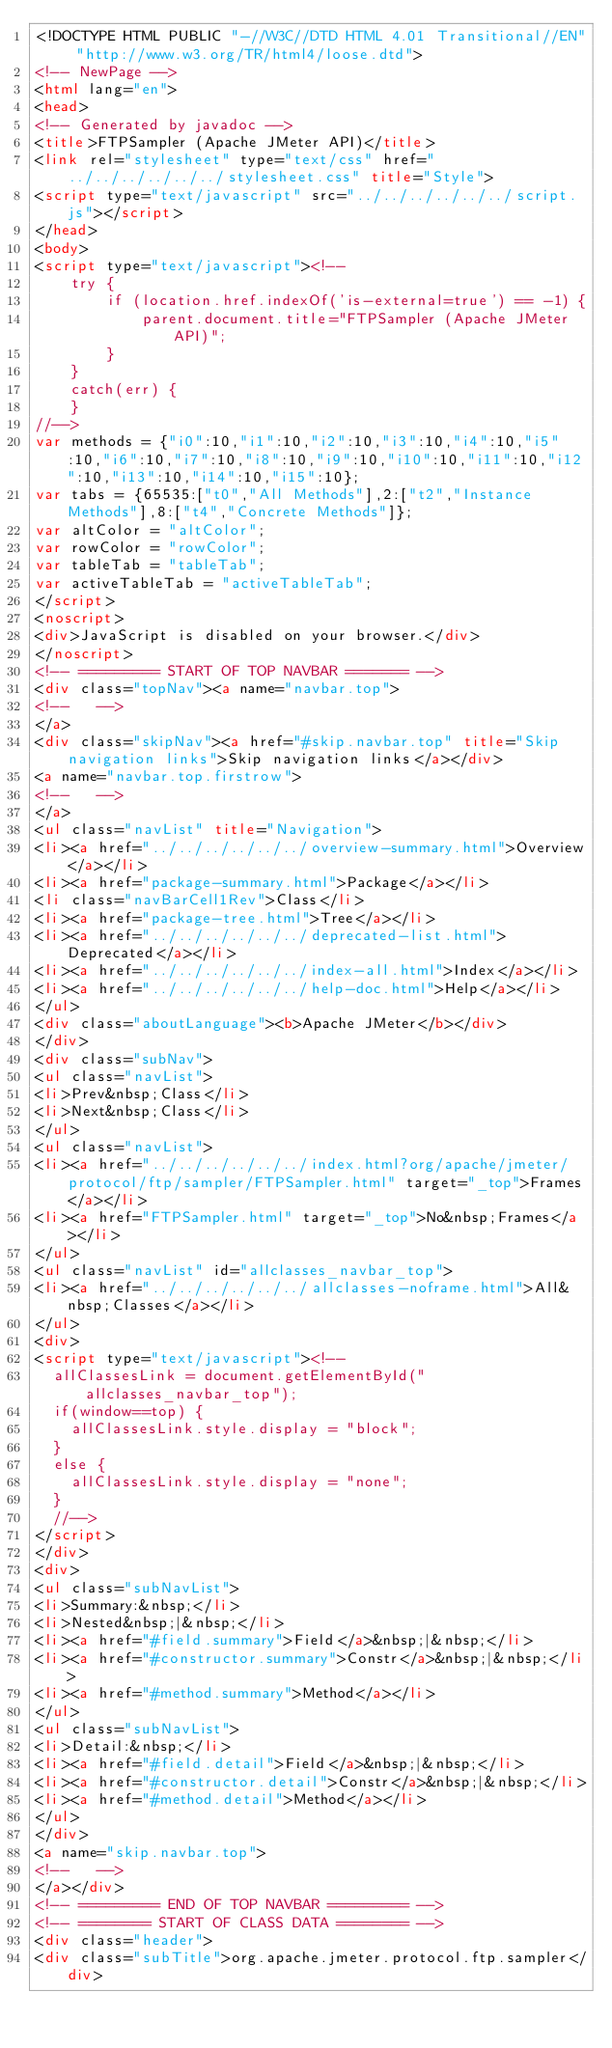Convert code to text. <code><loc_0><loc_0><loc_500><loc_500><_HTML_><!DOCTYPE HTML PUBLIC "-//W3C//DTD HTML 4.01 Transitional//EN" "http://www.w3.org/TR/html4/loose.dtd">
<!-- NewPage -->
<html lang="en">
<head>
<!-- Generated by javadoc -->
<title>FTPSampler (Apache JMeter API)</title>
<link rel="stylesheet" type="text/css" href="../../../../../../stylesheet.css" title="Style">
<script type="text/javascript" src="../../../../../../script.js"></script>
</head>
<body>
<script type="text/javascript"><!--
    try {
        if (location.href.indexOf('is-external=true') == -1) {
            parent.document.title="FTPSampler (Apache JMeter API)";
        }
    }
    catch(err) {
    }
//-->
var methods = {"i0":10,"i1":10,"i2":10,"i3":10,"i4":10,"i5":10,"i6":10,"i7":10,"i8":10,"i9":10,"i10":10,"i11":10,"i12":10,"i13":10,"i14":10,"i15":10};
var tabs = {65535:["t0","All Methods"],2:["t2","Instance Methods"],8:["t4","Concrete Methods"]};
var altColor = "altColor";
var rowColor = "rowColor";
var tableTab = "tableTab";
var activeTableTab = "activeTableTab";
</script>
<noscript>
<div>JavaScript is disabled on your browser.</div>
</noscript>
<!-- ========= START OF TOP NAVBAR ======= -->
<div class="topNav"><a name="navbar.top">
<!--   -->
</a>
<div class="skipNav"><a href="#skip.navbar.top" title="Skip navigation links">Skip navigation links</a></div>
<a name="navbar.top.firstrow">
<!--   -->
</a>
<ul class="navList" title="Navigation">
<li><a href="../../../../../../overview-summary.html">Overview</a></li>
<li><a href="package-summary.html">Package</a></li>
<li class="navBarCell1Rev">Class</li>
<li><a href="package-tree.html">Tree</a></li>
<li><a href="../../../../../../deprecated-list.html">Deprecated</a></li>
<li><a href="../../../../../../index-all.html">Index</a></li>
<li><a href="../../../../../../help-doc.html">Help</a></li>
</ul>
<div class="aboutLanguage"><b>Apache JMeter</b></div>
</div>
<div class="subNav">
<ul class="navList">
<li>Prev&nbsp;Class</li>
<li>Next&nbsp;Class</li>
</ul>
<ul class="navList">
<li><a href="../../../../../../index.html?org/apache/jmeter/protocol/ftp/sampler/FTPSampler.html" target="_top">Frames</a></li>
<li><a href="FTPSampler.html" target="_top">No&nbsp;Frames</a></li>
</ul>
<ul class="navList" id="allclasses_navbar_top">
<li><a href="../../../../../../allclasses-noframe.html">All&nbsp;Classes</a></li>
</ul>
<div>
<script type="text/javascript"><!--
  allClassesLink = document.getElementById("allclasses_navbar_top");
  if(window==top) {
    allClassesLink.style.display = "block";
  }
  else {
    allClassesLink.style.display = "none";
  }
  //-->
</script>
</div>
<div>
<ul class="subNavList">
<li>Summary:&nbsp;</li>
<li>Nested&nbsp;|&nbsp;</li>
<li><a href="#field.summary">Field</a>&nbsp;|&nbsp;</li>
<li><a href="#constructor.summary">Constr</a>&nbsp;|&nbsp;</li>
<li><a href="#method.summary">Method</a></li>
</ul>
<ul class="subNavList">
<li>Detail:&nbsp;</li>
<li><a href="#field.detail">Field</a>&nbsp;|&nbsp;</li>
<li><a href="#constructor.detail">Constr</a>&nbsp;|&nbsp;</li>
<li><a href="#method.detail">Method</a></li>
</ul>
</div>
<a name="skip.navbar.top">
<!--   -->
</a></div>
<!-- ========= END OF TOP NAVBAR ========= -->
<!-- ======== START OF CLASS DATA ======== -->
<div class="header">
<div class="subTitle">org.apache.jmeter.protocol.ftp.sampler</div></code> 